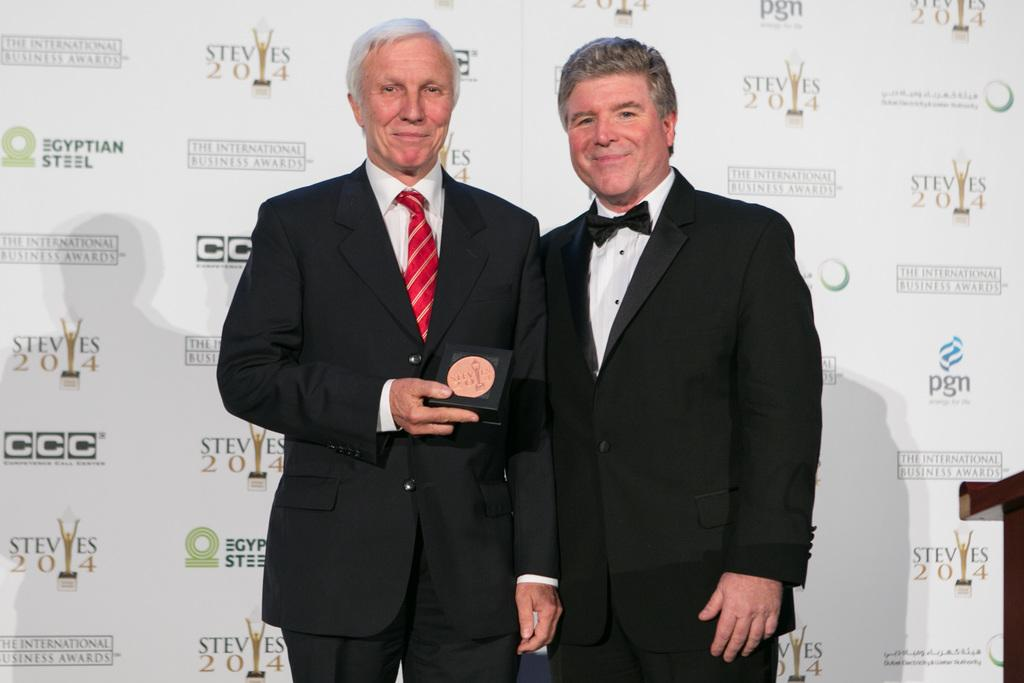How many people are in the image? There are two men standing in the image. What are the men wearing? The men are wearing formal suits. What is one of the men holding in his hand? One man is holding a box in his hand. What can be seen in the background of the image? There is a banner visible in the background. Can you hear the guitar being played in the image? There is no guitar present in the image, so it cannot be heard or played. 